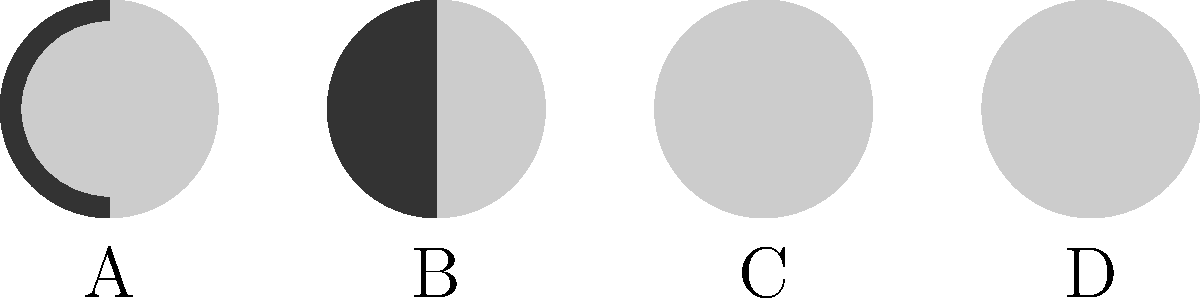As an artist learning GLSL for creating visually stunning animations, you want to visualize the phases of the moon using basic shapes. Which of the labeled moon phases (A, B, C, or D) represents the First Quarter moon? To answer this question, let's break down the phases of the moon and how they're represented in the image:

1. The moon phases are caused by the changing angles between the sun, moon, and Earth as the moon orbits around our planet.

2. In the image, we see four different moon phases represented using basic shapes:

   A: This shows a thin crescent on the right side, representing a Waxing Crescent moon.
   B: This shows half of the moon illuminated on the right side.
   C: This shows a full circle, representing a Full Moon.
   D: This shows half of the moon illuminated on the left side.

3. The First Quarter moon occurs when exactly half of the moon's visible surface is illuminated on the right side from Earth's perspective.

4. Looking at the options, we can see that B matches this description perfectly: half of the circle is illuminated on the right side.

5. The other phases shown are:
   A: Waxing Crescent (shortly after New Moon)
   C: Full Moon
   D: Last Quarter (often called Third Quarter)

Therefore, the First Quarter moon is represented by the image labeled B.
Answer: B 